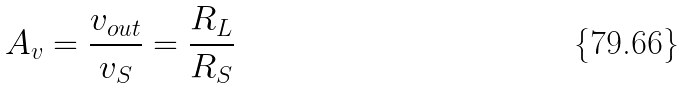<formula> <loc_0><loc_0><loc_500><loc_500>A _ { v } = \frac { v _ { o u t } } { v _ { S } } = \frac { R _ { L } } { R _ { S } }</formula> 